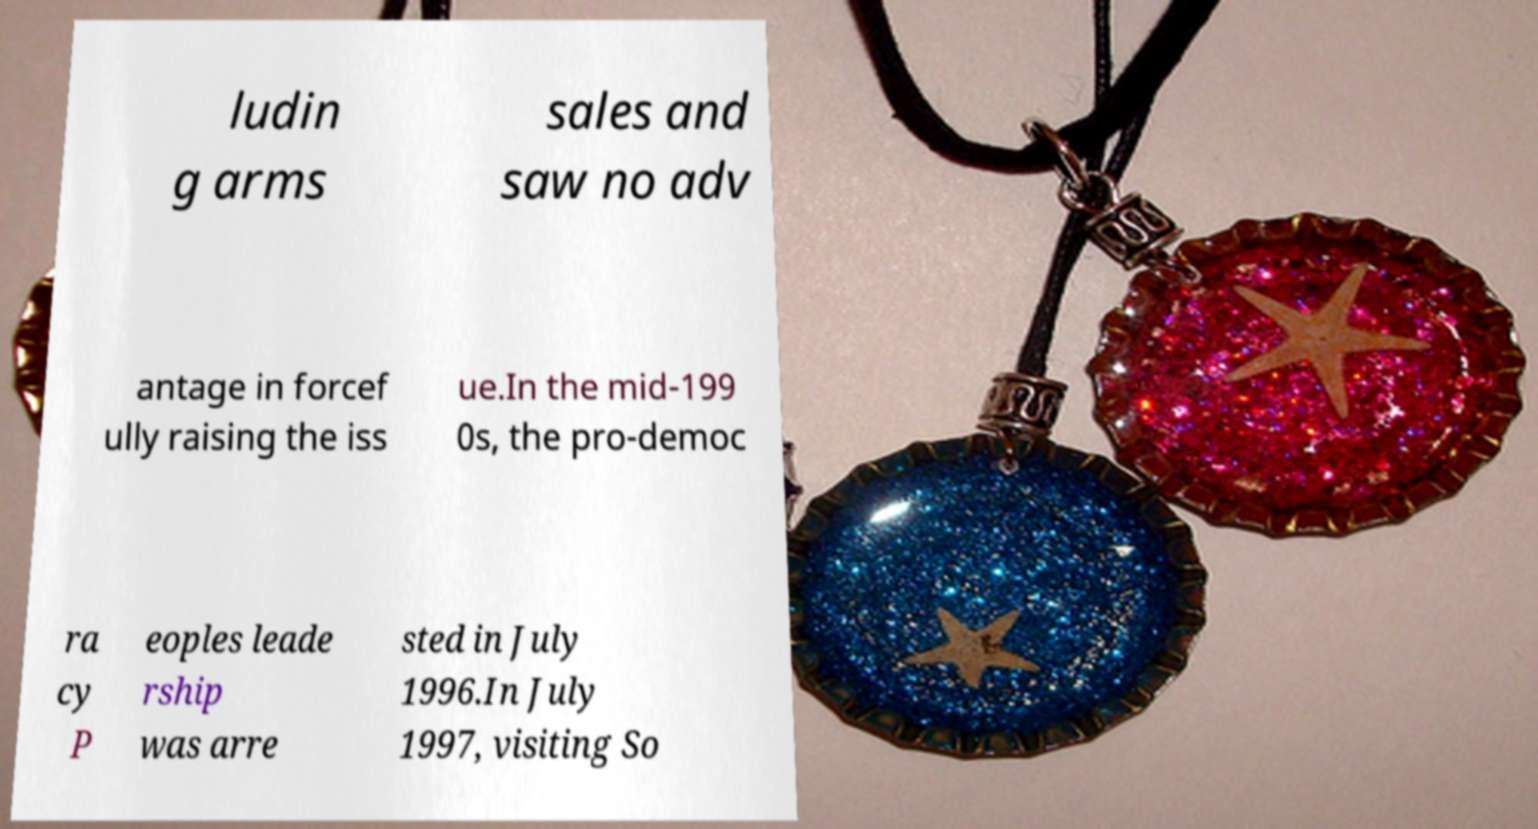Please identify and transcribe the text found in this image. ludin g arms sales and saw no adv antage in forcef ully raising the iss ue.In the mid-199 0s, the pro-democ ra cy P eoples leade rship was arre sted in July 1996.In July 1997, visiting So 